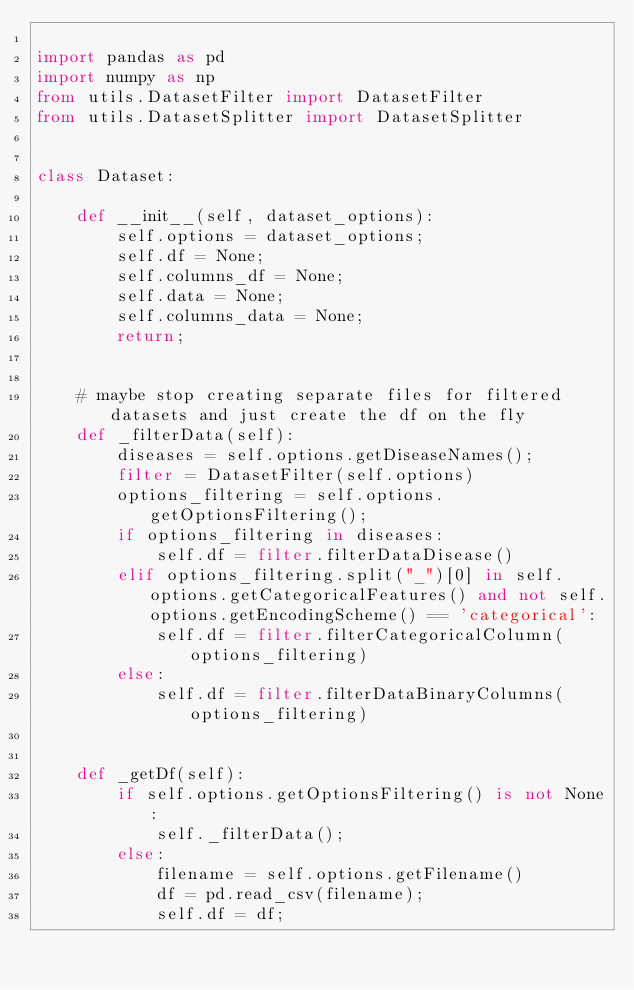Convert code to text. <code><loc_0><loc_0><loc_500><loc_500><_Python_>
import pandas as pd
import numpy as np
from utils.DatasetFilter import DatasetFilter
from utils.DatasetSplitter import DatasetSplitter


class Dataset:
    
    def __init__(self, dataset_options):
        self.options = dataset_options;
        self.df = None;
        self.columns_df = None;
        self.data = None;
        self.columns_data = None;
        return;


    # maybe stop creating separate files for filtered datasets and just create the df on the fly
    def _filterData(self):
        diseases = self.options.getDiseaseNames();
        filter = DatasetFilter(self.options)
        options_filtering = self.options.getOptionsFiltering();
        if options_filtering in diseases:
            self.df = filter.filterDataDisease()
        elif options_filtering.split("_")[0] in self.options.getCategoricalFeatures() and not self.options.getEncodingScheme() == 'categorical':
            self.df = filter.filterCategoricalColumn(options_filtering)
        else:
            self.df = filter.filterDataBinaryColumns(options_filtering)


    def _getDf(self):
        if self.options.getOptionsFiltering() is not None:
            self._filterData();
        else:
            filename = self.options.getFilename()
            df = pd.read_csv(filename);
            self.df = df;
    
</code> 